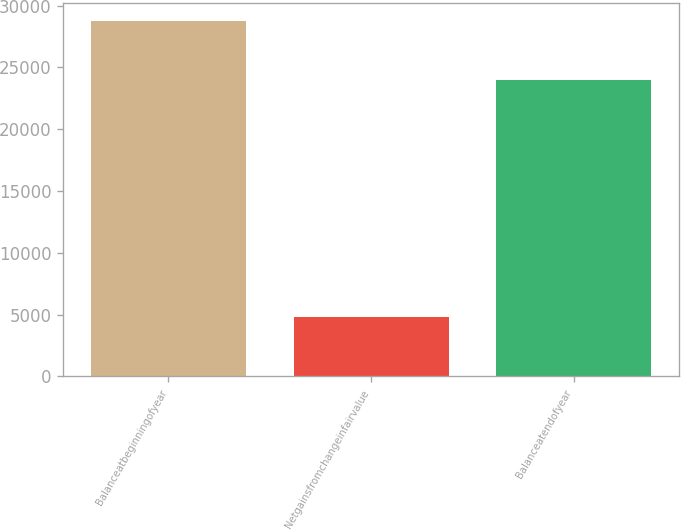<chart> <loc_0><loc_0><loc_500><loc_500><bar_chart><fcel>Balanceatbeginningofyear<fcel>Netgainsfromchangeinfairvalue<fcel>Balanceatendofyear<nl><fcel>28770<fcel>4790<fcel>23980<nl></chart> 